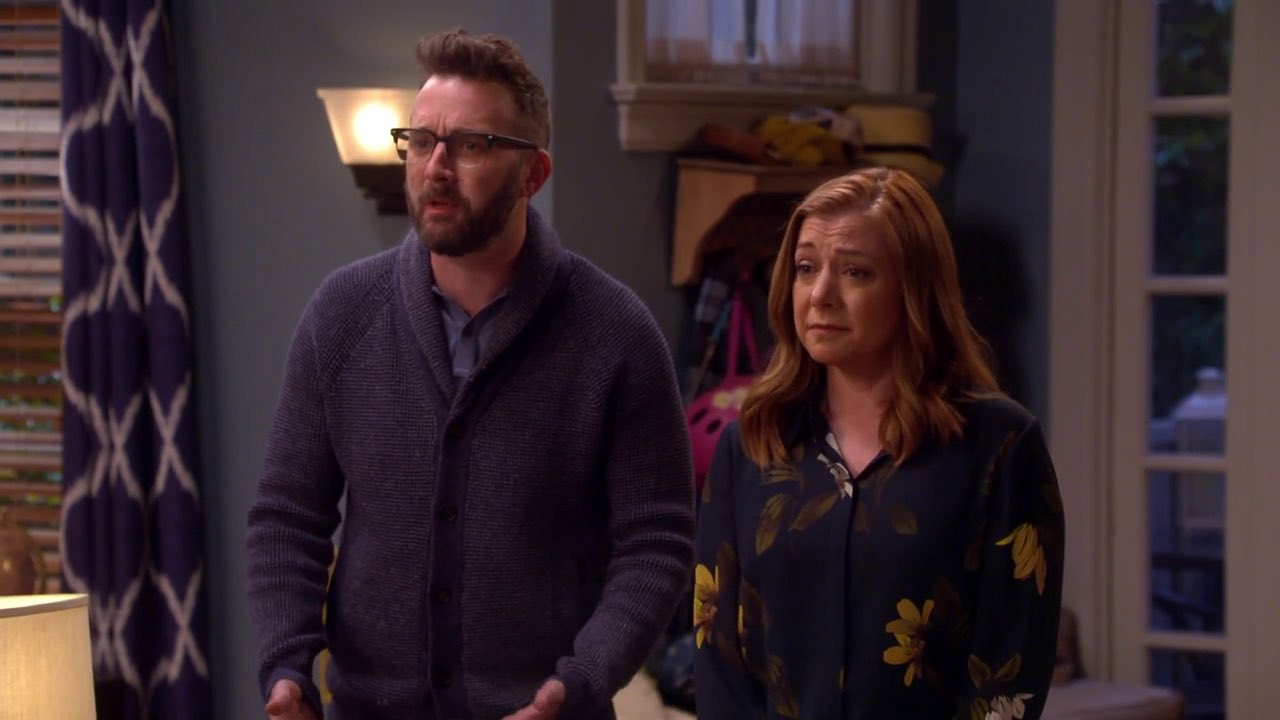What are they looking at? In the image, the man and woman are both looking intently towards the left side of the frame. They could be responding to an unexpected noise, a sudden event, or someone entering the room abruptly. Their expressions of concern imply that whatever they are seeing or hearing is serious or unexpected. Why would they be concerned? Their expressions suggest a situation that may have caught them by surprise or invoked a sense of worry. This could range from a personal matter, such as a family issue, to an external event like an emergency or an alarming piece of news. 